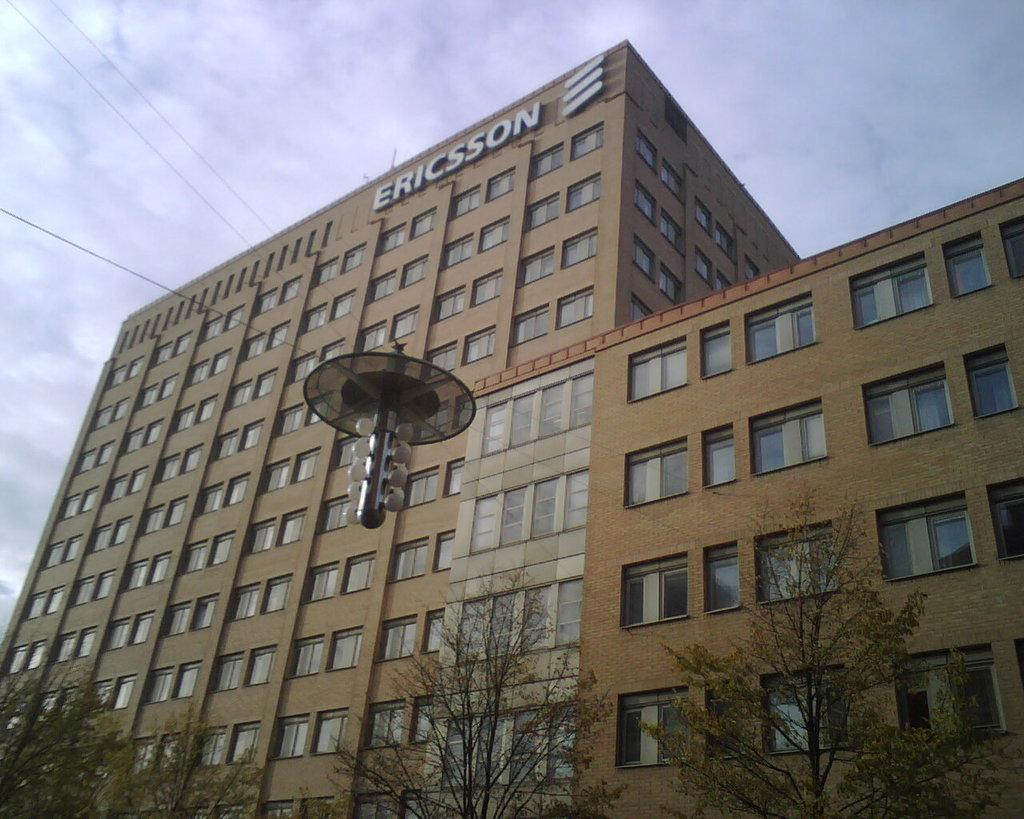What type of structure is visible in the image? There is a building in the image. What is the color of the building? The building is brown in color. What type of vegetation is at the bottom of the image? There are trees at the bottom of the image. What can be seen in the sky at the top of the image? There are clouds in the sky at the top of the image. What is present in the middle of the image? There are wires in the middle of the image. What is attached to the wires? There are lights on the wires. What type of basketball game is happening in the image? There is no basketball game present in the image. What emotion is being expressed by the building in the image? Buildings do not express emotions, so this question cannot be answered. 